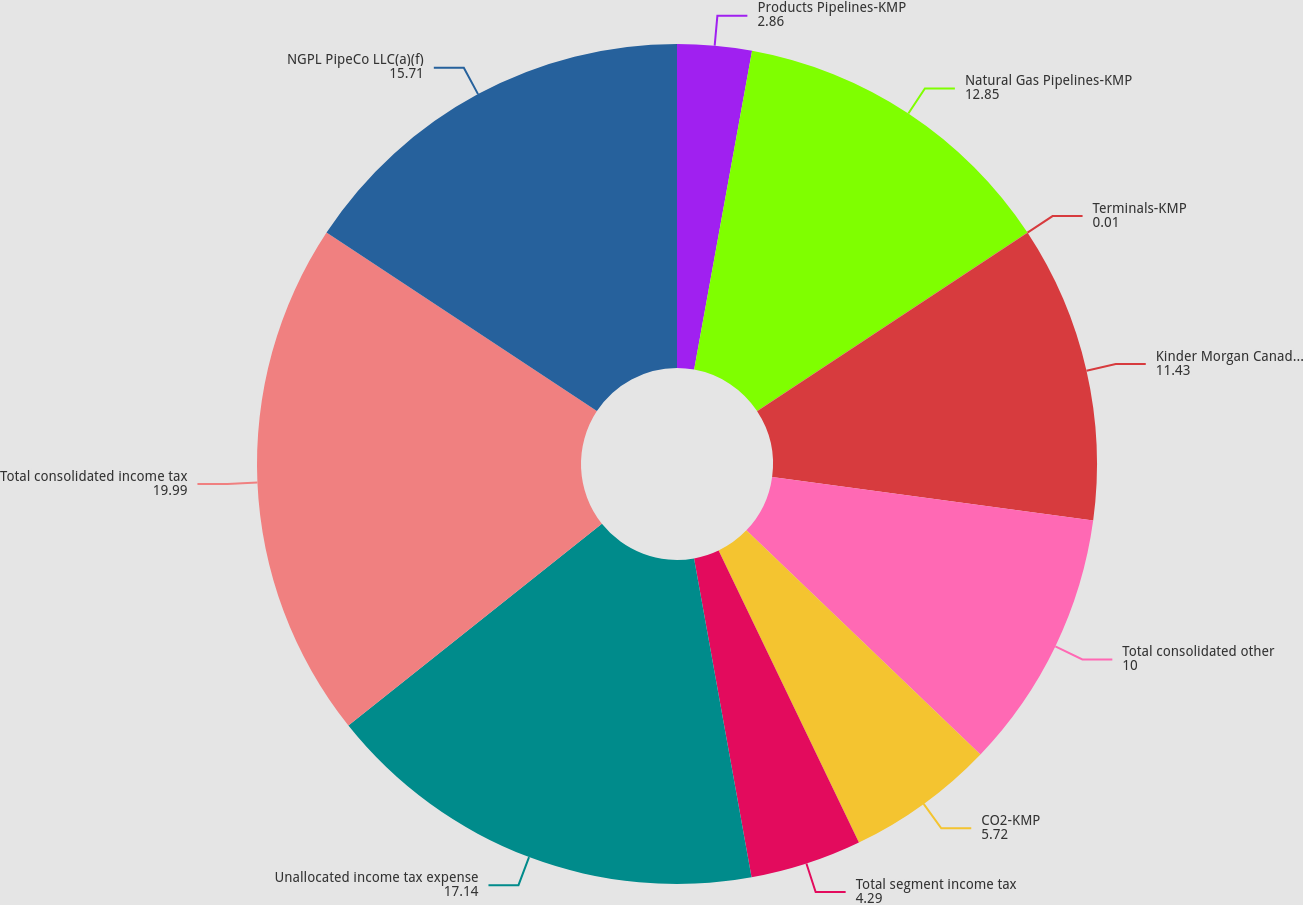Convert chart to OTSL. <chart><loc_0><loc_0><loc_500><loc_500><pie_chart><fcel>Products Pipelines-KMP<fcel>Natural Gas Pipelines-KMP<fcel>Terminals-KMP<fcel>Kinder Morgan Canada-KMP<fcel>Total consolidated other<fcel>CO2-KMP<fcel>Total segment income tax<fcel>Unallocated income tax expense<fcel>Total consolidated income tax<fcel>NGPL PipeCo LLC(a)(f)<nl><fcel>2.86%<fcel>12.85%<fcel>0.01%<fcel>11.43%<fcel>10.0%<fcel>5.72%<fcel>4.29%<fcel>17.14%<fcel>19.99%<fcel>15.71%<nl></chart> 